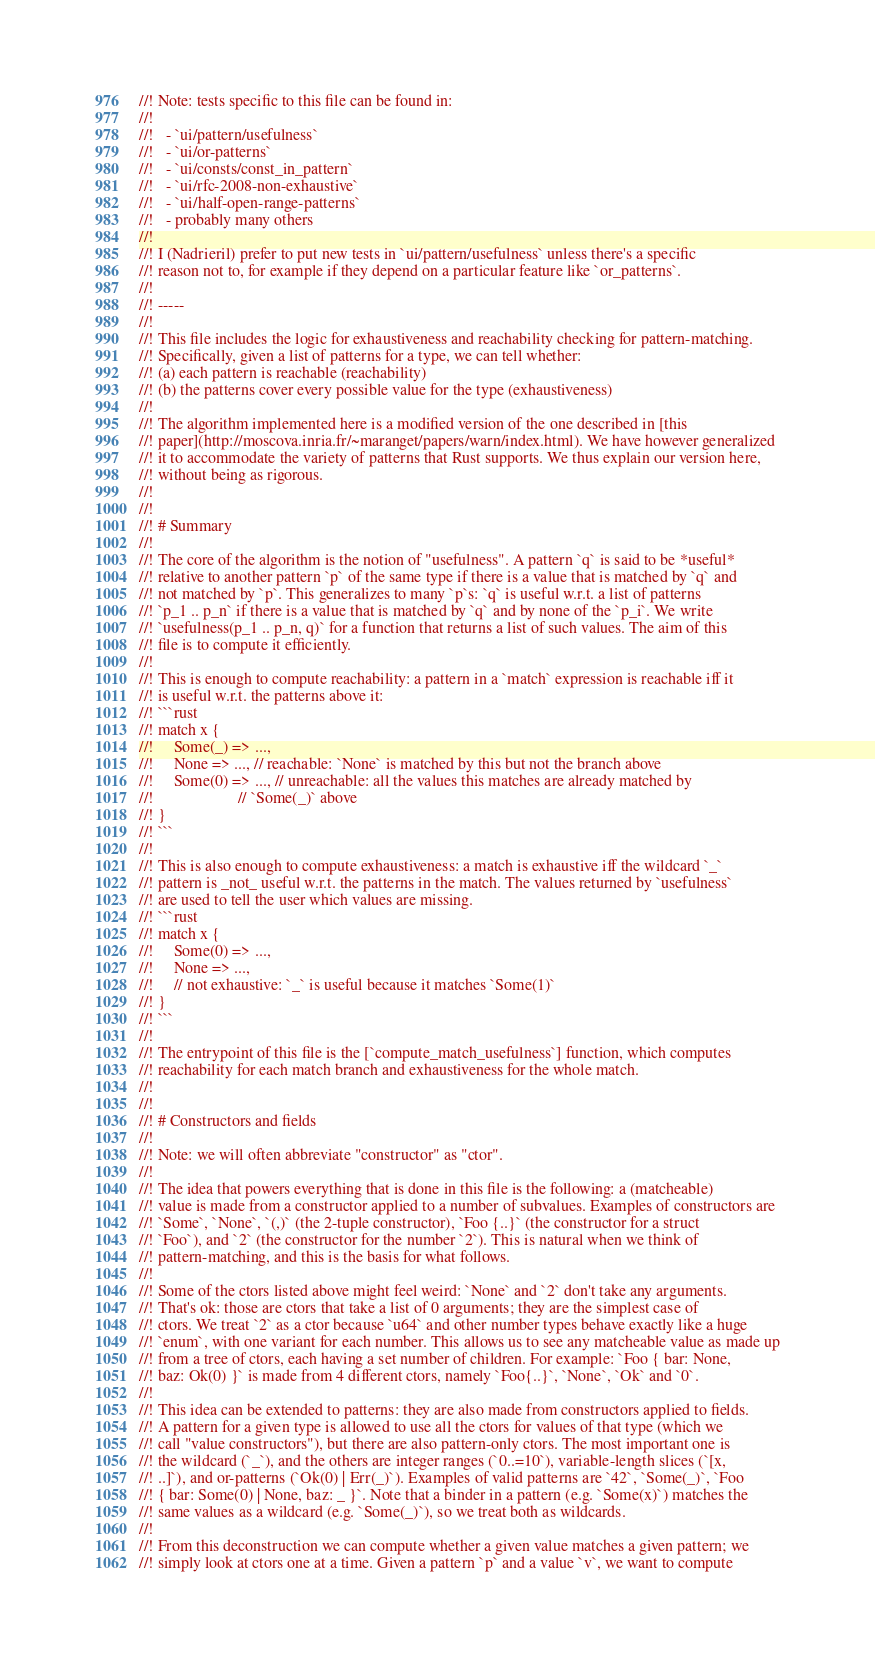<code> <loc_0><loc_0><loc_500><loc_500><_Rust_>//! Note: tests specific to this file can be found in:
//!
//!   - `ui/pattern/usefulness`
//!   - `ui/or-patterns`
//!   - `ui/consts/const_in_pattern`
//!   - `ui/rfc-2008-non-exhaustive`
//!   - `ui/half-open-range-patterns`
//!   - probably many others
//!
//! I (Nadrieril) prefer to put new tests in `ui/pattern/usefulness` unless there's a specific
//! reason not to, for example if they depend on a particular feature like `or_patterns`.
//!
//! -----
//!
//! This file includes the logic for exhaustiveness and reachability checking for pattern-matching.
//! Specifically, given a list of patterns for a type, we can tell whether:
//! (a) each pattern is reachable (reachability)
//! (b) the patterns cover every possible value for the type (exhaustiveness)
//!
//! The algorithm implemented here is a modified version of the one described in [this
//! paper](http://moscova.inria.fr/~maranget/papers/warn/index.html). We have however generalized
//! it to accommodate the variety of patterns that Rust supports. We thus explain our version here,
//! without being as rigorous.
//!
//!
//! # Summary
//!
//! The core of the algorithm is the notion of "usefulness". A pattern `q` is said to be *useful*
//! relative to another pattern `p` of the same type if there is a value that is matched by `q` and
//! not matched by `p`. This generalizes to many `p`s: `q` is useful w.r.t. a list of patterns
//! `p_1 .. p_n` if there is a value that is matched by `q` and by none of the `p_i`. We write
//! `usefulness(p_1 .. p_n, q)` for a function that returns a list of such values. The aim of this
//! file is to compute it efficiently.
//!
//! This is enough to compute reachability: a pattern in a `match` expression is reachable iff it
//! is useful w.r.t. the patterns above it:
//! ```rust
//! match x {
//!     Some(_) => ...,
//!     None => ..., // reachable: `None` is matched by this but not the branch above
//!     Some(0) => ..., // unreachable: all the values this matches are already matched by
//!                     // `Some(_)` above
//! }
//! ```
//!
//! This is also enough to compute exhaustiveness: a match is exhaustive iff the wildcard `_`
//! pattern is _not_ useful w.r.t. the patterns in the match. The values returned by `usefulness`
//! are used to tell the user which values are missing.
//! ```rust
//! match x {
//!     Some(0) => ...,
//!     None => ...,
//!     // not exhaustive: `_` is useful because it matches `Some(1)`
//! }
//! ```
//!
//! The entrypoint of this file is the [`compute_match_usefulness`] function, which computes
//! reachability for each match branch and exhaustiveness for the whole match.
//!
//!
//! # Constructors and fields
//!
//! Note: we will often abbreviate "constructor" as "ctor".
//!
//! The idea that powers everything that is done in this file is the following: a (matcheable)
//! value is made from a constructor applied to a number of subvalues. Examples of constructors are
//! `Some`, `None`, `(,)` (the 2-tuple constructor), `Foo {..}` (the constructor for a struct
//! `Foo`), and `2` (the constructor for the number `2`). This is natural when we think of
//! pattern-matching, and this is the basis for what follows.
//!
//! Some of the ctors listed above might feel weird: `None` and `2` don't take any arguments.
//! That's ok: those are ctors that take a list of 0 arguments; they are the simplest case of
//! ctors. We treat `2` as a ctor because `u64` and other number types behave exactly like a huge
//! `enum`, with one variant for each number. This allows us to see any matcheable value as made up
//! from a tree of ctors, each having a set number of children. For example: `Foo { bar: None,
//! baz: Ok(0) }` is made from 4 different ctors, namely `Foo{..}`, `None`, `Ok` and `0`.
//!
//! This idea can be extended to patterns: they are also made from constructors applied to fields.
//! A pattern for a given type is allowed to use all the ctors for values of that type (which we
//! call "value constructors"), but there are also pattern-only ctors. The most important one is
//! the wildcard (`_`), and the others are integer ranges (`0..=10`), variable-length slices (`[x,
//! ..]`), and or-patterns (`Ok(0) | Err(_)`). Examples of valid patterns are `42`, `Some(_)`, `Foo
//! { bar: Some(0) | None, baz: _ }`. Note that a binder in a pattern (e.g. `Some(x)`) matches the
//! same values as a wildcard (e.g. `Some(_)`), so we treat both as wildcards.
//!
//! From this deconstruction we can compute whether a given value matches a given pattern; we
//! simply look at ctors one at a time. Given a pattern `p` and a value `v`, we want to compute</code> 